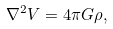<formula> <loc_0><loc_0><loc_500><loc_500>\nabla ^ { 2 } V = 4 \pi G \rho ,</formula> 